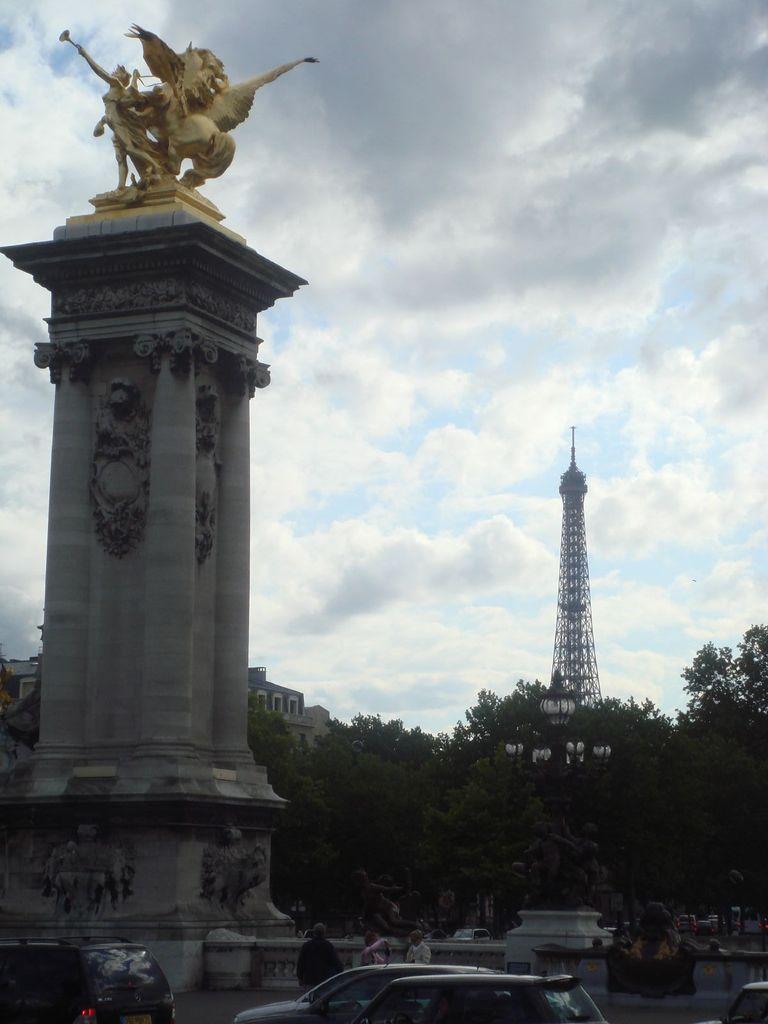Can you describe this image briefly? In this picture we can see a statue on the pillar. In front of the pillar, there are vehicles and some people on the road. On the tight side of the pillar, those are looking like statues and lights. Behind the pillar there are trees, a building, a tower and the cloudy sky. 